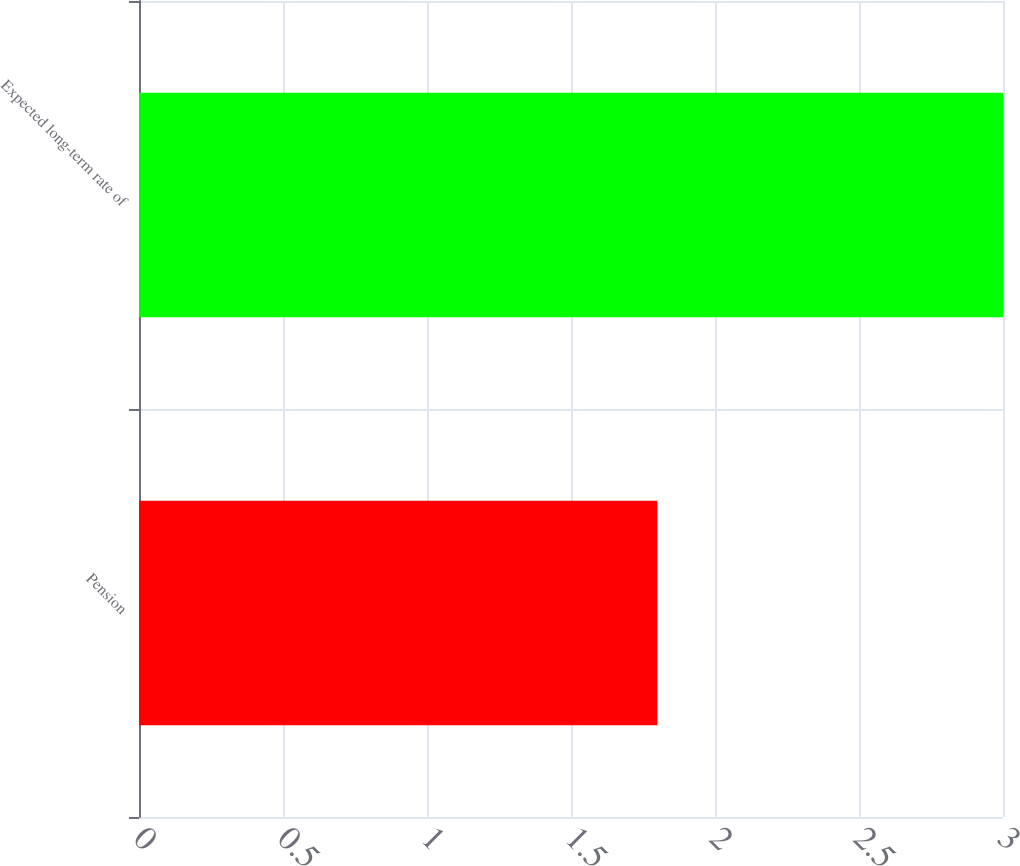Convert chart. <chart><loc_0><loc_0><loc_500><loc_500><bar_chart><fcel>Pension<fcel>Expected long-term rate of<nl><fcel>1.8<fcel>3<nl></chart> 